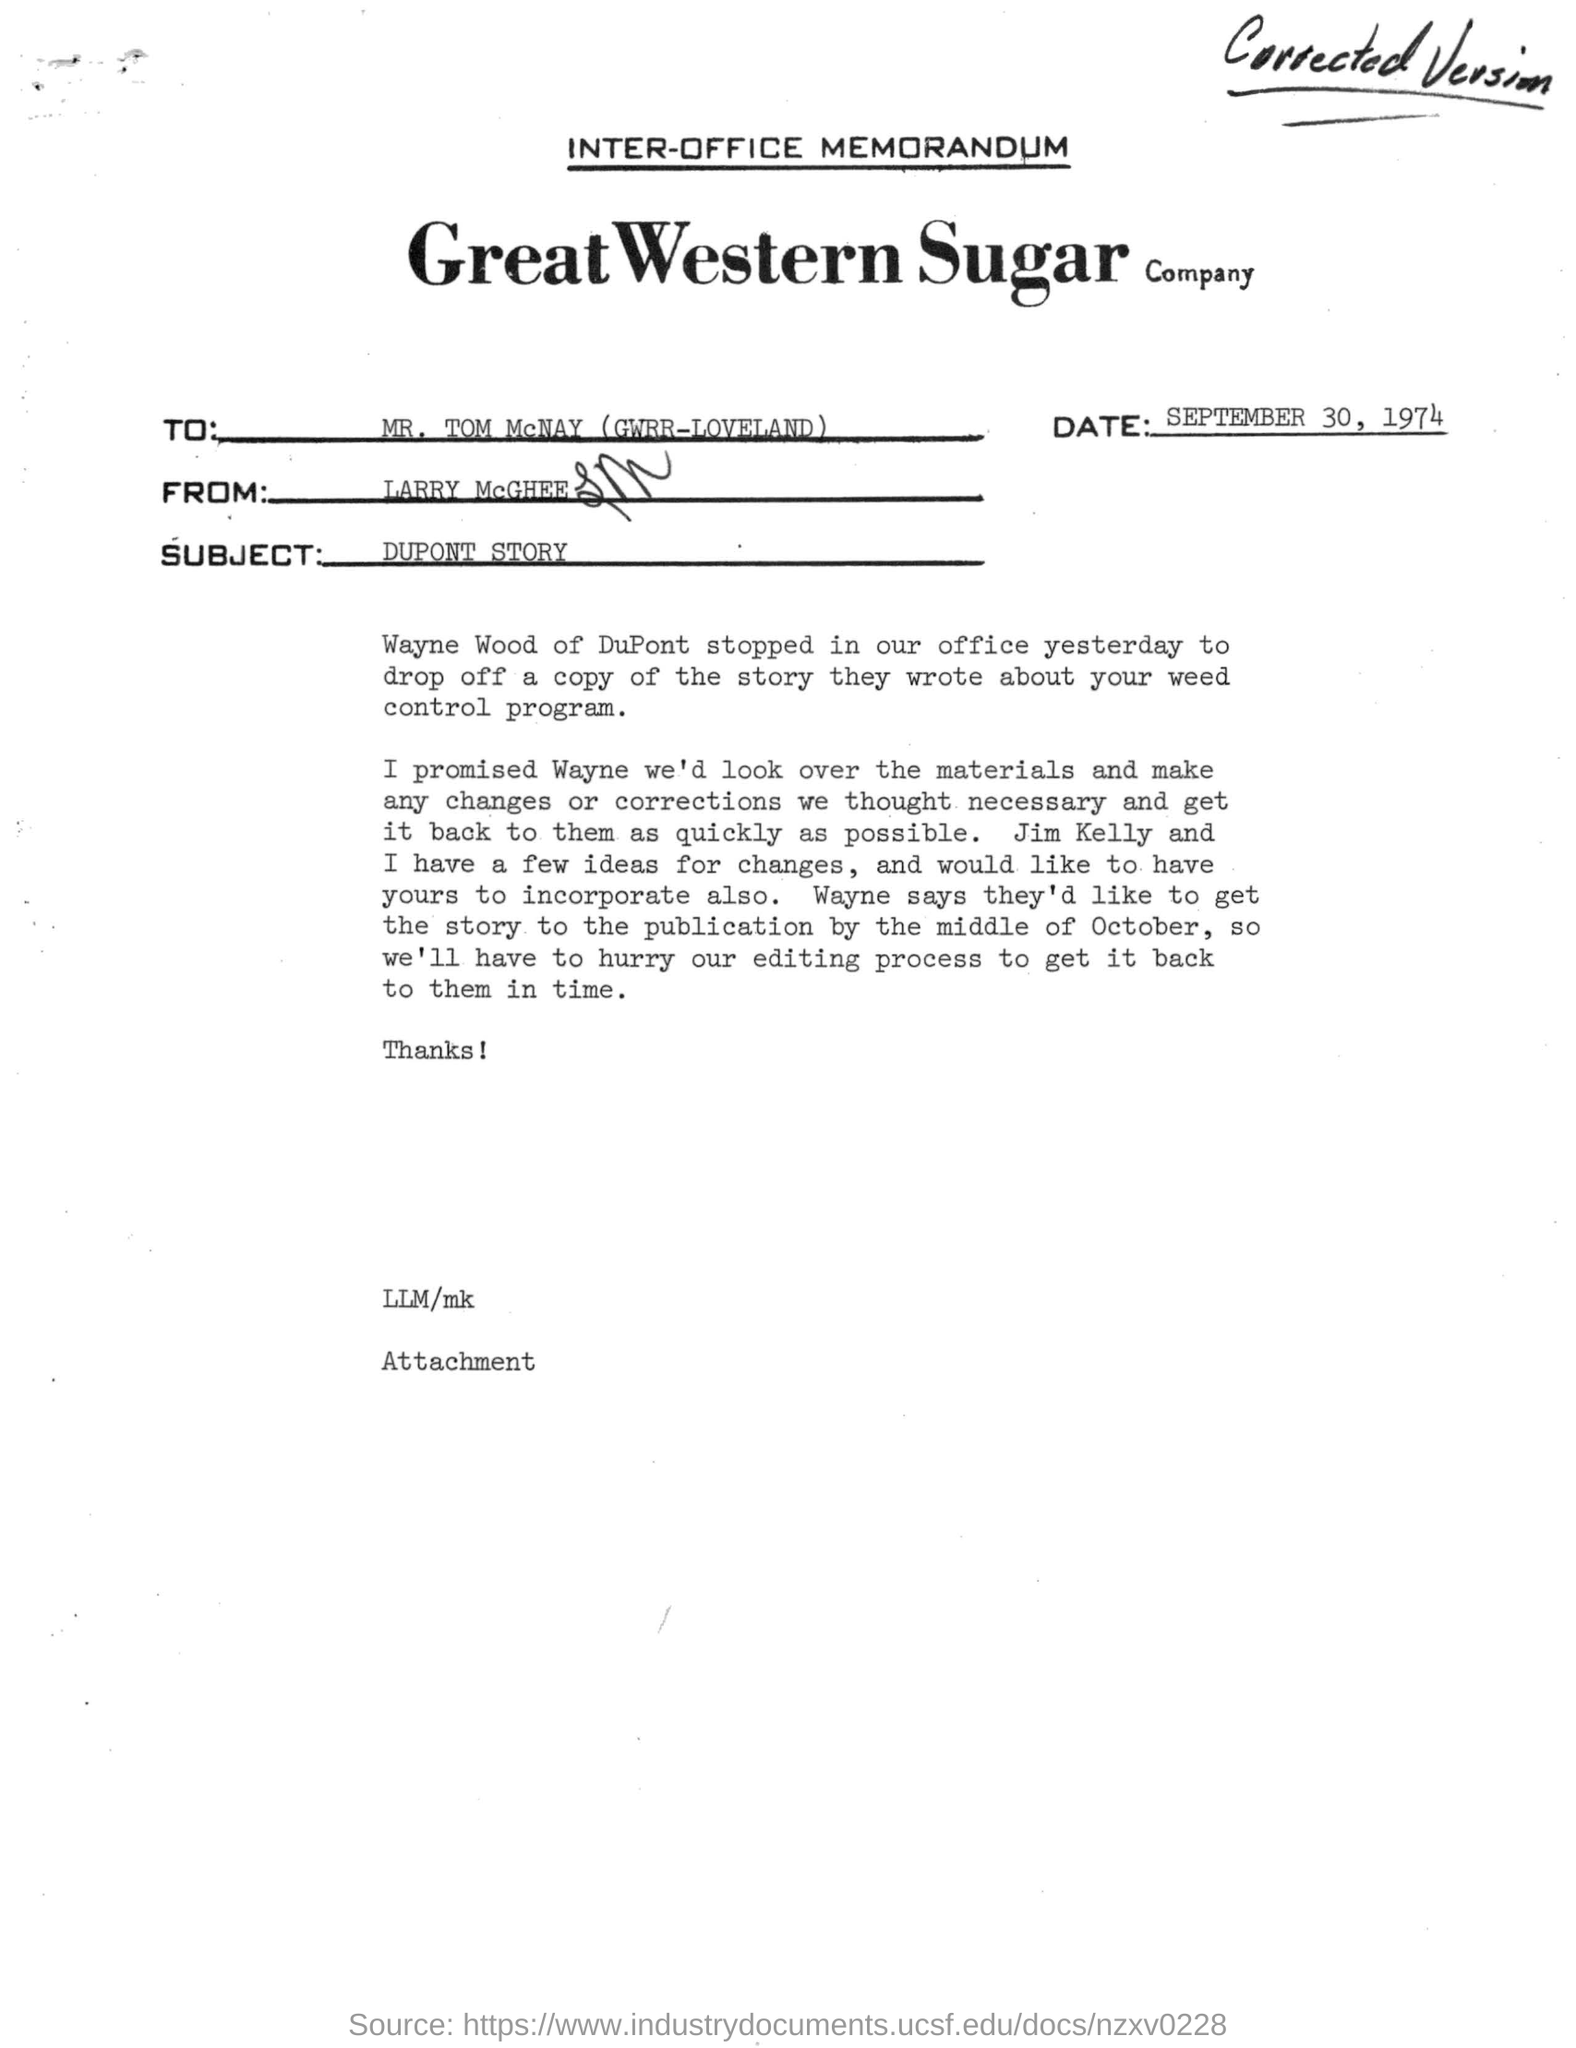Draw attention to some important aspects in this diagram. It is stated that the story should be published by October, as declared by Wayne. A memorandum was written by Larry Mcghee to Mr. Tom McNAY, asking for clarification on a certain matter. The subject of the inter-office memorandum is "DuPont Story. On September 30, 1974, a letter was dated. 